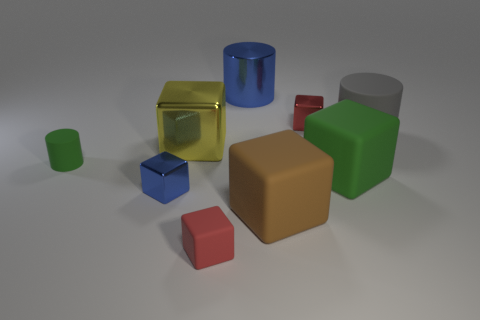Subtract all brown blocks. How many blocks are left? 5 Subtract all yellow cubes. How many cubes are left? 5 Add 1 tiny blue rubber cylinders. How many objects exist? 10 Subtract all gray blocks. Subtract all purple cylinders. How many blocks are left? 6 Subtract all cylinders. How many objects are left? 6 Add 5 gray cylinders. How many gray cylinders exist? 6 Subtract 0 purple balls. How many objects are left? 9 Subtract all small rubber cylinders. Subtract all small red metallic objects. How many objects are left? 7 Add 2 small blue shiny cubes. How many small blue shiny cubes are left? 3 